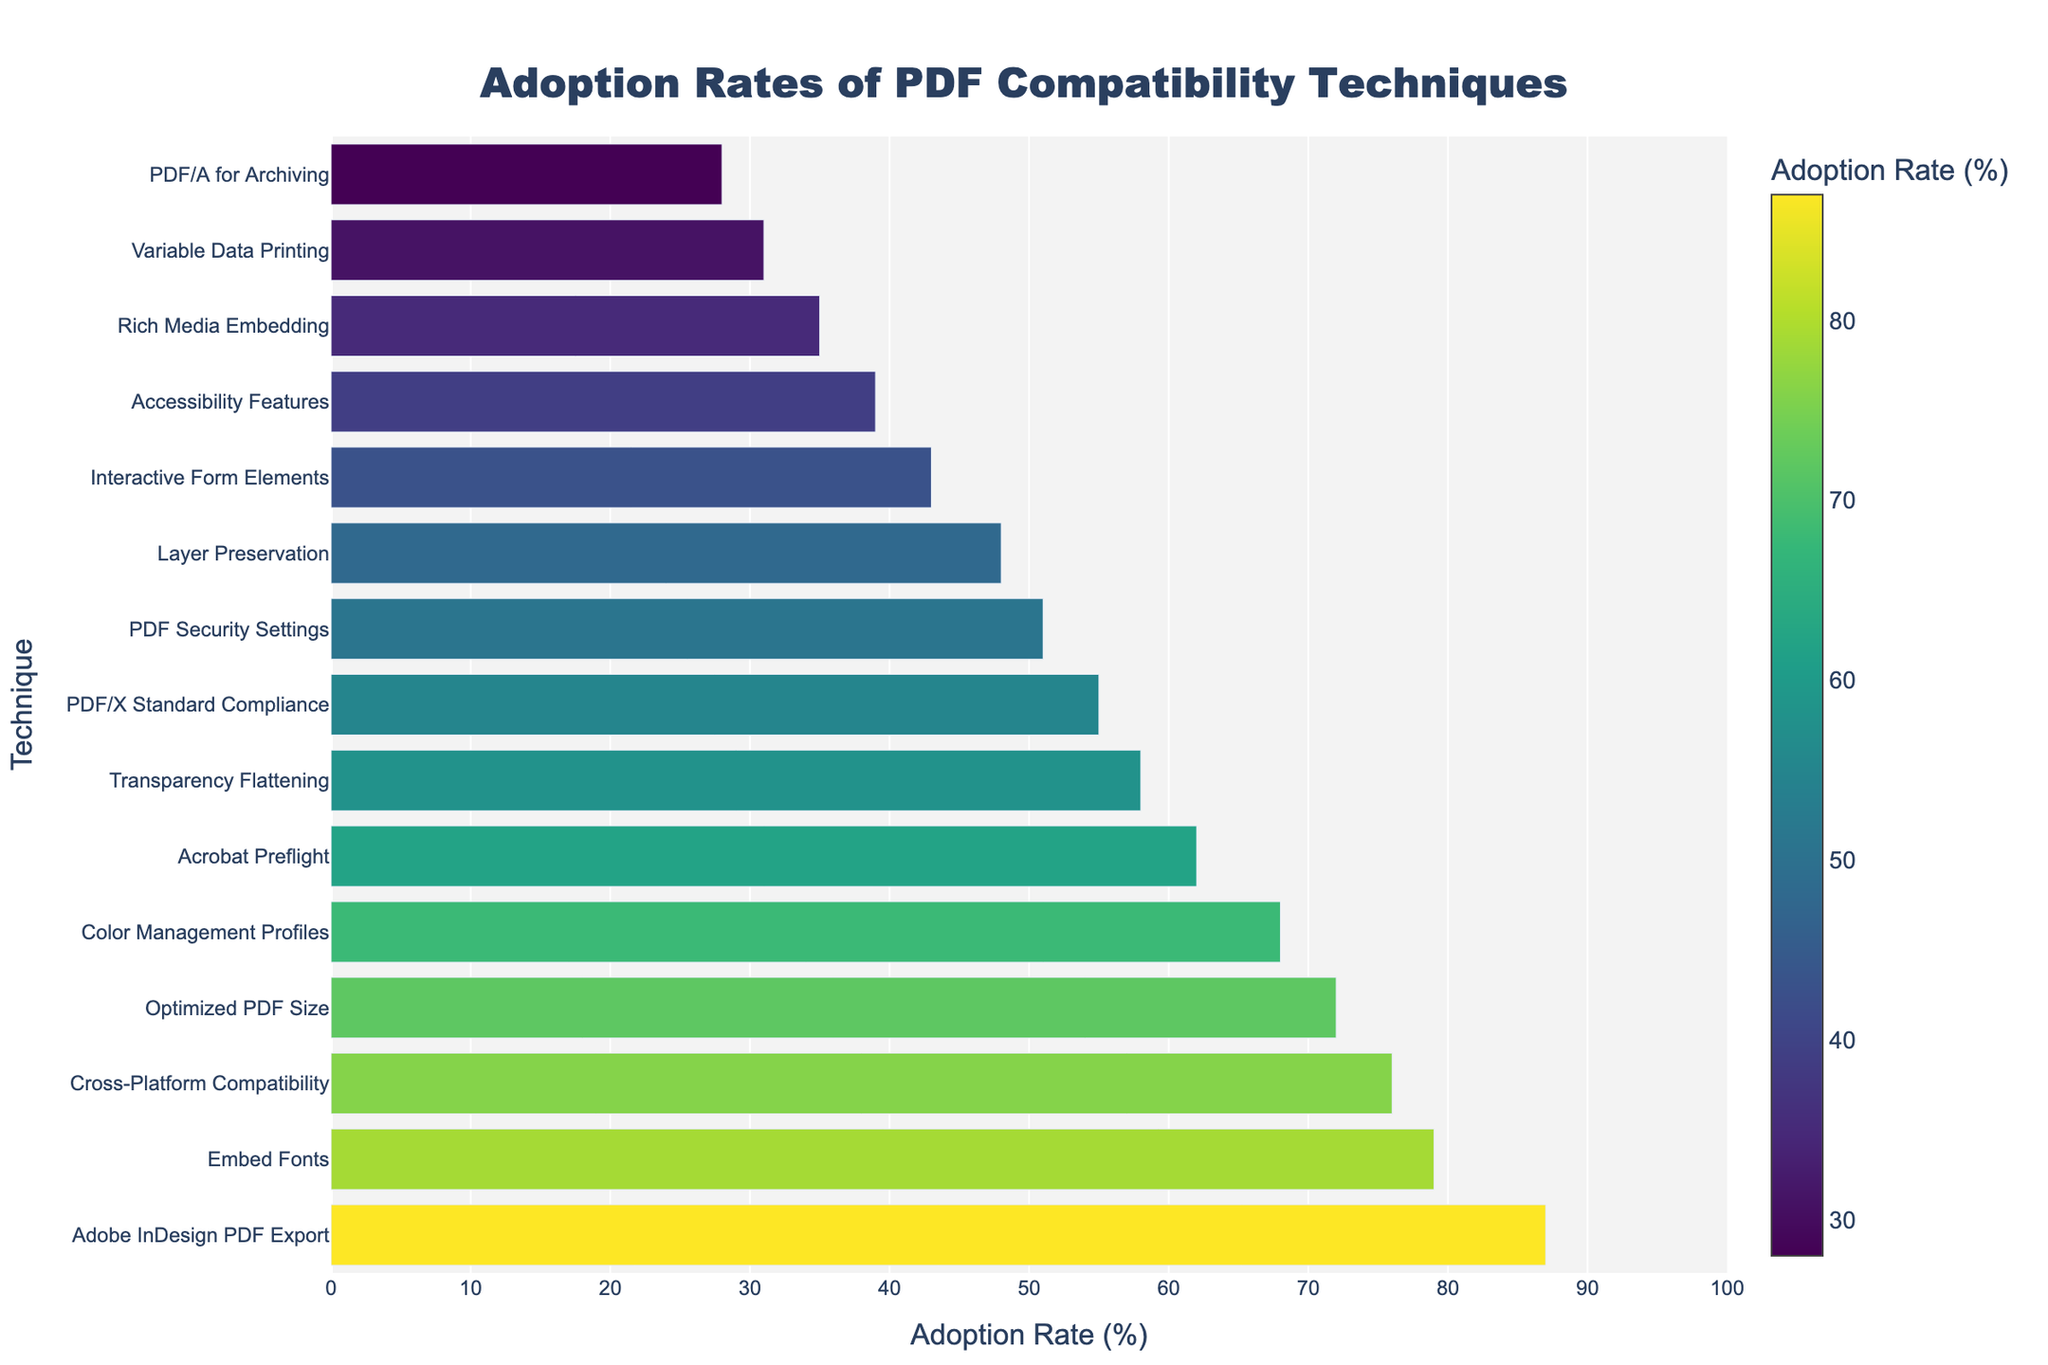Which technique has the highest adoption rate? The highest bar represents the technique with the highest adoption rate. The top technique is "Adobe InDesign PDF Export" with an adoption rate of 87%.
Answer: Adobe InDesign PDF Export Which technique has the lowest adoption rate? The smallest bar represents the technique with the lowest adoption rate. The bottom technique is "PDF/A for Archiving" with an adoption rate of 28%.
Answer: PDF/A for Archiving Compare the adoption rates of "Embed Fonts" and "Color Management Profiles." Which is higher? By comparing the lengths of the bars for both techniques, "Embed Fonts" has an adoption rate of 79% while "Color Management Profiles" has an adoption rate of 68%. Therefore, "Embed Fonts" is higher.
Answer: Embed Fonts What is the difference in adoption rates between "Interactive Form Elements" and "Rich Media Embedding"? Find the bars for both techniques; "Interactive Form Elements" is at 43% and "Rich Media Embedding" is at 35%. The difference is 43% - 35% = 8%.
Answer: 8% What is the average adoption rate of the techniques that have an adoption rate greater than 60%? Identify the techniques above 60%, sum their rates, and divide by the number of techniques. Techniques: Adobe InDesign PDF Export (87), Acrobat Preflight (62), Embed Fonts (79), Color Management Profiles (68), Optimized PDF Size (72), Cross-Platform Compatibility (76). Sum: 87 + 62 + 79 + 68 + 72 + 76 = 444. Number of techniques: 6. Average: 444/6 = 74%.
Answer: 74% Which techniques have an adoption rate between 50% and 60%? Find the techniques whose bar lengths correspond to rates between 50% and 60%. These are "PDF/X Standard Compliance" (55%), "PDF Security Settings" (51%), and "Transparency Flattening" (58%).
Answer: PDF/X Standard Compliance, PDF Security Settings, Transparency Flattening How many techniques have an adoption rate less than 40%? Count the techniques whose bars show an adoption rate of less than 40%. These are "Accessibility Features" (39%), "Rich Media Embedding" (35%), "PDF/A for Archiving" (28%), and "Variable Data Printing" (31%). There are 4 such techniques.
Answer: 4 What are the techniques with an adoption rate of over 70%? Identify bars representing techniques with rates above 70%. These are: Adobe InDesign PDF Export (87), Embed Fonts (79), Color Management Profiles (68), Optimized PDF Size (72), and Cross-Platform Compatibility (76).
Answer: Adobe InDesign PDF Export, Embed Fonts, Optimized PDF Size, Cross-Platform Compatibility Is there a noticeable color difference for the technique with the highest adoption rate compared to other techniques? The highest adoption rate bar should have the most intense color in the colorscale used (likely the darkest or lightest shade). Adobe InDesign PDF Export at 87% should visually appear different from lower adoption rate techniques.
Answer: Yes Which technique has an adoption rate closest to the median value of all shown techniques? Calculate the median value by ordering adoption rates: [28, 31, 35, 39, 43, 48, 51, 55, 58, 62, 68, 72, 76, 79, 87]. The median (middle value) is 55%. The technique closest to this is "PDF/X Standard Compliance" with an adoption rate of 55%.
Answer: PDF/X Standard Compliance 